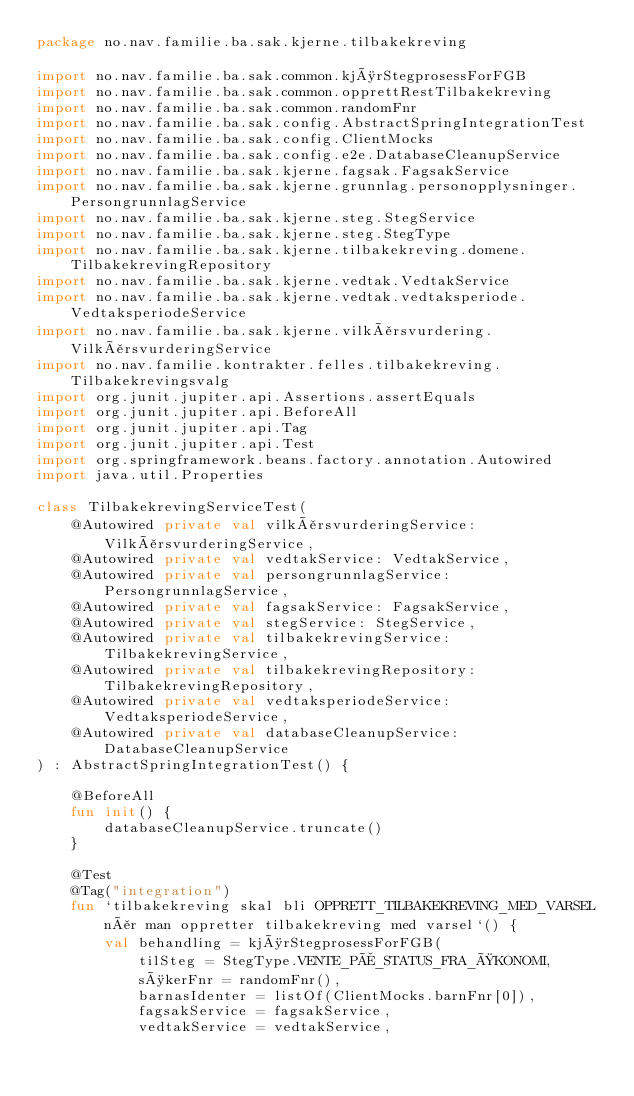<code> <loc_0><loc_0><loc_500><loc_500><_Kotlin_>package no.nav.familie.ba.sak.kjerne.tilbakekreving

import no.nav.familie.ba.sak.common.kjørStegprosessForFGB
import no.nav.familie.ba.sak.common.opprettRestTilbakekreving
import no.nav.familie.ba.sak.common.randomFnr
import no.nav.familie.ba.sak.config.AbstractSpringIntegrationTest
import no.nav.familie.ba.sak.config.ClientMocks
import no.nav.familie.ba.sak.config.e2e.DatabaseCleanupService
import no.nav.familie.ba.sak.kjerne.fagsak.FagsakService
import no.nav.familie.ba.sak.kjerne.grunnlag.personopplysninger.PersongrunnlagService
import no.nav.familie.ba.sak.kjerne.steg.StegService
import no.nav.familie.ba.sak.kjerne.steg.StegType
import no.nav.familie.ba.sak.kjerne.tilbakekreving.domene.TilbakekrevingRepository
import no.nav.familie.ba.sak.kjerne.vedtak.VedtakService
import no.nav.familie.ba.sak.kjerne.vedtak.vedtaksperiode.VedtaksperiodeService
import no.nav.familie.ba.sak.kjerne.vilkårsvurdering.VilkårsvurderingService
import no.nav.familie.kontrakter.felles.tilbakekreving.Tilbakekrevingsvalg
import org.junit.jupiter.api.Assertions.assertEquals
import org.junit.jupiter.api.BeforeAll
import org.junit.jupiter.api.Tag
import org.junit.jupiter.api.Test
import org.springframework.beans.factory.annotation.Autowired
import java.util.Properties

class TilbakekrevingServiceTest(
    @Autowired private val vilkårsvurderingService: VilkårsvurderingService,
    @Autowired private val vedtakService: VedtakService,
    @Autowired private val persongrunnlagService: PersongrunnlagService,
    @Autowired private val fagsakService: FagsakService,
    @Autowired private val stegService: StegService,
    @Autowired private val tilbakekrevingService: TilbakekrevingService,
    @Autowired private val tilbakekrevingRepository: TilbakekrevingRepository,
    @Autowired private val vedtaksperiodeService: VedtaksperiodeService,
    @Autowired private val databaseCleanupService: DatabaseCleanupService
) : AbstractSpringIntegrationTest() {

    @BeforeAll
    fun init() {
        databaseCleanupService.truncate()
    }

    @Test
    @Tag("integration")
    fun `tilbakekreving skal bli OPPRETT_TILBAKEKREVING_MED_VARSEL når man oppretter tilbakekreving med varsel`() {
        val behandling = kjørStegprosessForFGB(
            tilSteg = StegType.VENTE_PÅ_STATUS_FRA_ØKONOMI,
            søkerFnr = randomFnr(),
            barnasIdenter = listOf(ClientMocks.barnFnr[0]),
            fagsakService = fagsakService,
            vedtakService = vedtakService,</code> 